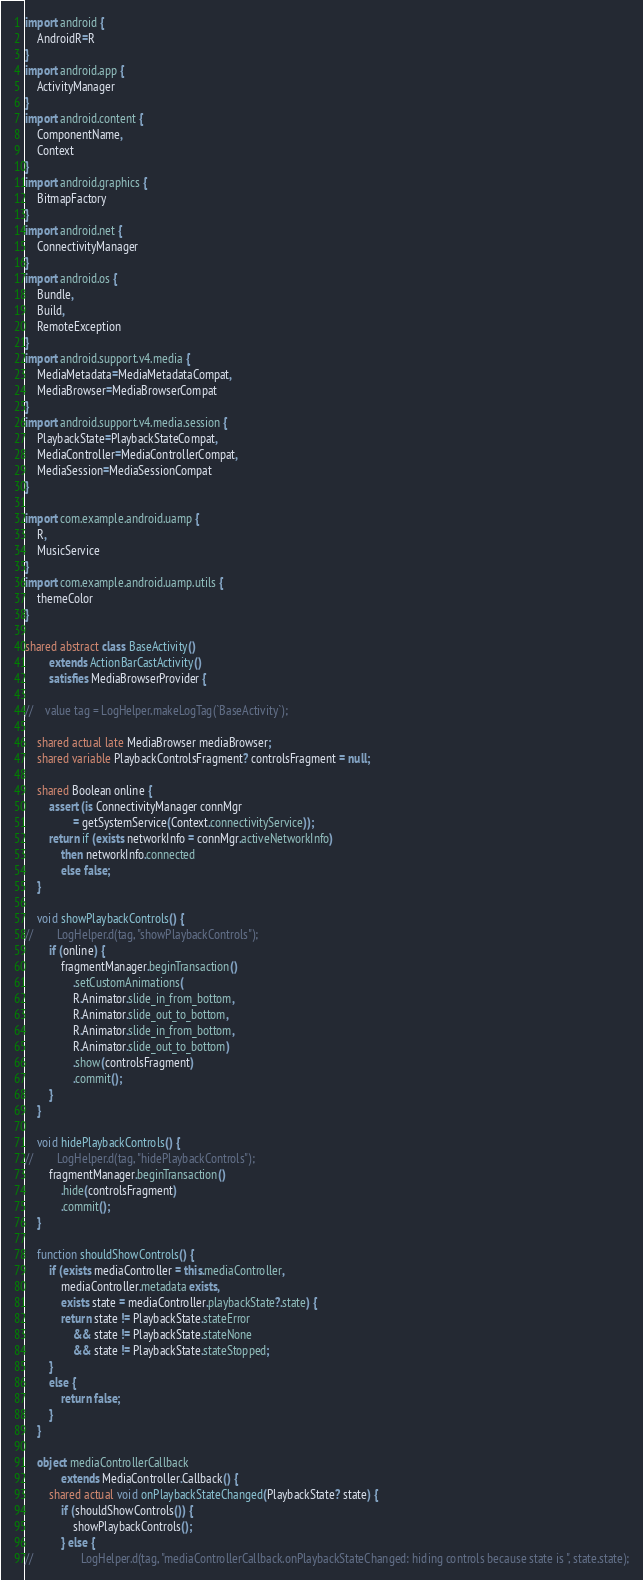Convert code to text. <code><loc_0><loc_0><loc_500><loc_500><_Ceylon_>import android {
    AndroidR=R
}
import android.app {
    ActivityManager
}
import android.content {
    ComponentName,
    Context
}
import android.graphics {
    BitmapFactory
}
import android.net {
    ConnectivityManager
}
import android.os {
    Bundle,
    Build,
    RemoteException
}
import android.support.v4.media {
    MediaMetadata=MediaMetadataCompat,
    MediaBrowser=MediaBrowserCompat
}
import android.support.v4.media.session {
    PlaybackState=PlaybackStateCompat,
    MediaController=MediaControllerCompat,
    MediaSession=MediaSessionCompat
}

import com.example.android.uamp {
    R,
    MusicService
}
import com.example.android.uamp.utils {
    themeColor
}

shared abstract class BaseActivity()
        extends ActionBarCastActivity()
        satisfies MediaBrowserProvider {

//    value tag = LogHelper.makeLogTag(`BaseActivity`);

    shared actual late MediaBrowser mediaBrowser;
    shared variable PlaybackControlsFragment? controlsFragment = null;

    shared Boolean online {
        assert (is ConnectivityManager connMgr
                = getSystemService(Context.connectivityService));
        return if (exists networkInfo = connMgr.activeNetworkInfo)
            then networkInfo.connected
            else false;
    }

    void showPlaybackControls() {
//        LogHelper.d(tag, "showPlaybackControls");
        if (online) {
            fragmentManager.beginTransaction()
                .setCustomAnimations(
                R.Animator.slide_in_from_bottom,
                R.Animator.slide_out_to_bottom,
                R.Animator.slide_in_from_bottom,
                R.Animator.slide_out_to_bottom)
                .show(controlsFragment)
                .commit();
        }
    }

    void hidePlaybackControls() {
//        LogHelper.d(tag, "hidePlaybackControls");
        fragmentManager.beginTransaction()
            .hide(controlsFragment)
            .commit();
    }

    function shouldShowControls() {
        if (exists mediaController = this.mediaController,
            mediaController.metadata exists,
            exists state = mediaController.playbackState?.state) {
            return state != PlaybackState.stateError
                && state != PlaybackState.stateNone
                && state != PlaybackState.stateStopped;
        }
        else {
            return false;
        }
    }

    object mediaControllerCallback
            extends MediaController.Callback() {
        shared actual void onPlaybackStateChanged(PlaybackState? state) {
            if (shouldShowControls()) {
                showPlaybackControls();
            } else {
//                LogHelper.d(tag, "mediaControllerCallback.onPlaybackStateChanged: hiding controls because state is ", state.state);</code> 